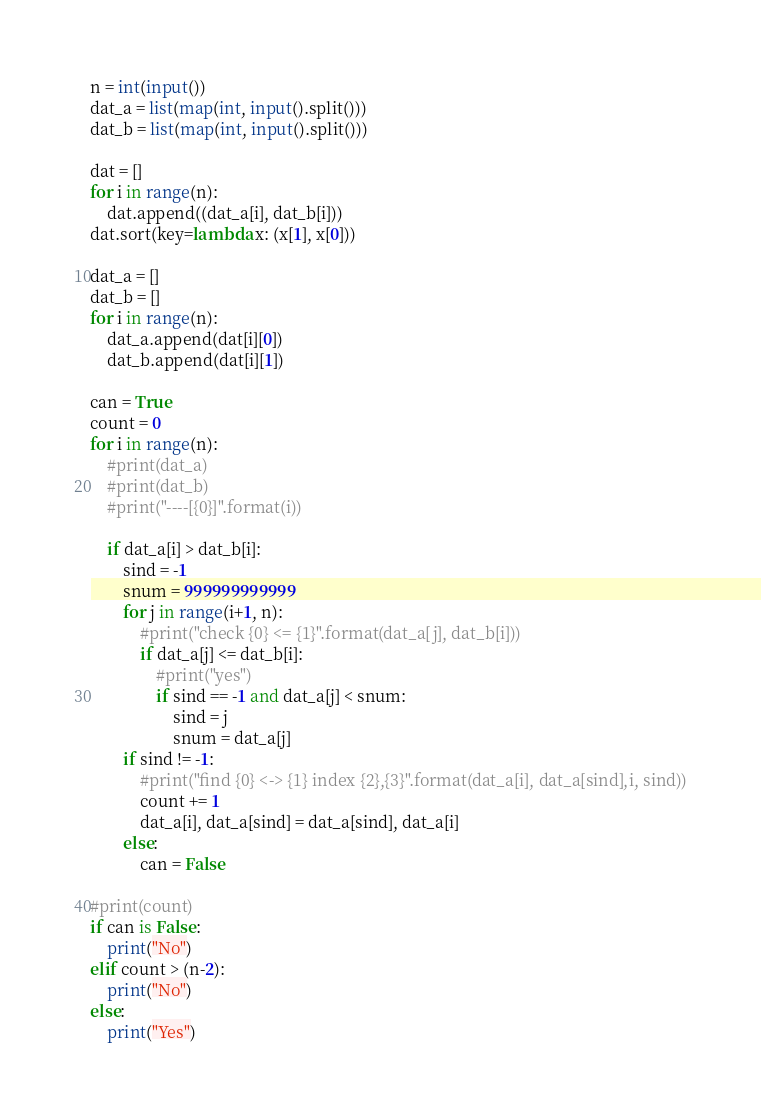<code> <loc_0><loc_0><loc_500><loc_500><_Python_>n = int(input())
dat_a = list(map(int, input().split()))
dat_b = list(map(int, input().split()))

dat = []
for i in range(n):
    dat.append((dat_a[i], dat_b[i]))
dat.sort(key=lambda x: (x[1], x[0]))

dat_a = []
dat_b = []
for i in range(n):
    dat_a.append(dat[i][0])
    dat_b.append(dat[i][1])

can = True
count = 0
for i in range(n):
    #print(dat_a)
    #print(dat_b)
    #print("----[{0}]".format(i))

    if dat_a[i] > dat_b[i]:
        sind = -1
        snum = 999999999999
        for j in range(i+1, n):
            #print("check {0} <= {1}".format(dat_a[j], dat_b[i]))
            if dat_a[j] <= dat_b[i]:
                #print("yes")
                if sind == -1 and dat_a[j] < snum:
                    sind = j
                    snum = dat_a[j]
        if sind != -1:
            #print("find {0} <-> {1} index {2},{3}".format(dat_a[i], dat_a[sind],i, sind))
            count += 1
            dat_a[i], dat_a[sind] = dat_a[sind], dat_a[i]
        else:
            can = False

#print(count)
if can is False:
    print("No")
elif count > (n-2):
    print("No")
else:
    print("Yes")
</code> 